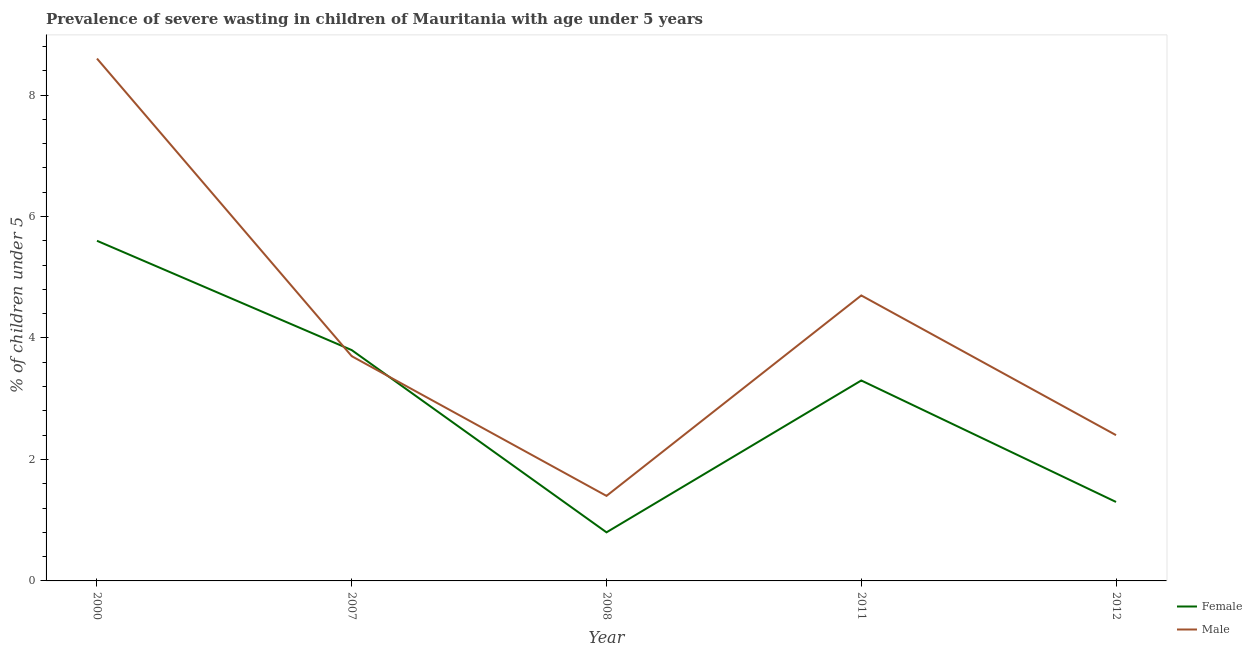Does the line corresponding to percentage of undernourished male children intersect with the line corresponding to percentage of undernourished female children?
Ensure brevity in your answer.  Yes. Is the number of lines equal to the number of legend labels?
Give a very brief answer. Yes. What is the percentage of undernourished female children in 2012?
Give a very brief answer. 1.3. Across all years, what is the maximum percentage of undernourished male children?
Make the answer very short. 8.6. Across all years, what is the minimum percentage of undernourished female children?
Your answer should be very brief. 0.8. What is the total percentage of undernourished female children in the graph?
Offer a terse response. 14.8. What is the difference between the percentage of undernourished female children in 2000 and that in 2007?
Make the answer very short. 1.8. What is the difference between the percentage of undernourished male children in 2008 and the percentage of undernourished female children in 2007?
Your response must be concise. -2.4. What is the average percentage of undernourished male children per year?
Give a very brief answer. 4.16. In the year 2011, what is the difference between the percentage of undernourished female children and percentage of undernourished male children?
Provide a short and direct response. -1.4. In how many years, is the percentage of undernourished male children greater than 1.6 %?
Provide a short and direct response. 4. What is the ratio of the percentage of undernourished female children in 2011 to that in 2012?
Make the answer very short. 2.54. Is the percentage of undernourished male children in 2007 less than that in 2012?
Keep it short and to the point. No. What is the difference between the highest and the second highest percentage of undernourished female children?
Keep it short and to the point. 1.8. What is the difference between the highest and the lowest percentage of undernourished female children?
Provide a succinct answer. 4.8. Is the sum of the percentage of undernourished male children in 2000 and 2011 greater than the maximum percentage of undernourished female children across all years?
Keep it short and to the point. Yes. Does the percentage of undernourished male children monotonically increase over the years?
Ensure brevity in your answer.  No. Is the percentage of undernourished female children strictly greater than the percentage of undernourished male children over the years?
Your answer should be very brief. No. How many years are there in the graph?
Your response must be concise. 5. What is the difference between two consecutive major ticks on the Y-axis?
Your answer should be compact. 2. Does the graph contain grids?
Offer a very short reply. No. Where does the legend appear in the graph?
Your answer should be very brief. Bottom right. How many legend labels are there?
Ensure brevity in your answer.  2. What is the title of the graph?
Provide a short and direct response. Prevalence of severe wasting in children of Mauritania with age under 5 years. Does "Private creditors" appear as one of the legend labels in the graph?
Offer a very short reply. No. What is the label or title of the X-axis?
Ensure brevity in your answer.  Year. What is the label or title of the Y-axis?
Your answer should be very brief.  % of children under 5. What is the  % of children under 5 in Female in 2000?
Offer a terse response. 5.6. What is the  % of children under 5 of Male in 2000?
Your answer should be compact. 8.6. What is the  % of children under 5 in Female in 2007?
Offer a terse response. 3.8. What is the  % of children under 5 of Male in 2007?
Keep it short and to the point. 3.7. What is the  % of children under 5 of Female in 2008?
Your answer should be very brief. 0.8. What is the  % of children under 5 of Male in 2008?
Make the answer very short. 1.4. What is the  % of children under 5 in Female in 2011?
Your answer should be very brief. 3.3. What is the  % of children under 5 of Male in 2011?
Keep it short and to the point. 4.7. What is the  % of children under 5 in Female in 2012?
Ensure brevity in your answer.  1.3. What is the  % of children under 5 of Male in 2012?
Your answer should be compact. 2.4. Across all years, what is the maximum  % of children under 5 of Female?
Your response must be concise. 5.6. Across all years, what is the maximum  % of children under 5 in Male?
Provide a short and direct response. 8.6. Across all years, what is the minimum  % of children under 5 of Female?
Your answer should be compact. 0.8. Across all years, what is the minimum  % of children under 5 in Male?
Make the answer very short. 1.4. What is the total  % of children under 5 in Female in the graph?
Offer a very short reply. 14.8. What is the total  % of children under 5 in Male in the graph?
Provide a succinct answer. 20.8. What is the difference between the  % of children under 5 in Female in 2000 and that in 2008?
Offer a terse response. 4.8. What is the difference between the  % of children under 5 of Male in 2000 and that in 2008?
Give a very brief answer. 7.2. What is the difference between the  % of children under 5 in Male in 2000 and that in 2012?
Provide a succinct answer. 6.2. What is the difference between the  % of children under 5 of Male in 2007 and that in 2011?
Provide a succinct answer. -1. What is the difference between the  % of children under 5 of Female in 2007 and that in 2012?
Keep it short and to the point. 2.5. What is the difference between the  % of children under 5 in Male in 2007 and that in 2012?
Your answer should be very brief. 1.3. What is the difference between the  % of children under 5 of Female in 2008 and that in 2011?
Ensure brevity in your answer.  -2.5. What is the difference between the  % of children under 5 in Male in 2008 and that in 2012?
Give a very brief answer. -1. What is the difference between the  % of children under 5 of Female in 2000 and the  % of children under 5 of Male in 2007?
Your answer should be very brief. 1.9. What is the difference between the  % of children under 5 of Female in 2000 and the  % of children under 5 of Male in 2008?
Offer a terse response. 4.2. What is the difference between the  % of children under 5 of Female in 2000 and the  % of children under 5 of Male in 2012?
Keep it short and to the point. 3.2. What is the difference between the  % of children under 5 in Female in 2007 and the  % of children under 5 in Male in 2008?
Offer a very short reply. 2.4. What is the difference between the  % of children under 5 of Female in 2007 and the  % of children under 5 of Male in 2011?
Your response must be concise. -0.9. What is the difference between the  % of children under 5 in Female in 2008 and the  % of children under 5 in Male in 2011?
Your answer should be compact. -3.9. What is the average  % of children under 5 of Female per year?
Your answer should be compact. 2.96. What is the average  % of children under 5 in Male per year?
Your answer should be very brief. 4.16. In the year 2008, what is the difference between the  % of children under 5 of Female and  % of children under 5 of Male?
Your answer should be very brief. -0.6. What is the ratio of the  % of children under 5 of Female in 2000 to that in 2007?
Give a very brief answer. 1.47. What is the ratio of the  % of children under 5 of Male in 2000 to that in 2007?
Offer a terse response. 2.32. What is the ratio of the  % of children under 5 of Male in 2000 to that in 2008?
Make the answer very short. 6.14. What is the ratio of the  % of children under 5 in Female in 2000 to that in 2011?
Provide a succinct answer. 1.7. What is the ratio of the  % of children under 5 in Male in 2000 to that in 2011?
Provide a succinct answer. 1.83. What is the ratio of the  % of children under 5 in Female in 2000 to that in 2012?
Ensure brevity in your answer.  4.31. What is the ratio of the  % of children under 5 of Male in 2000 to that in 2012?
Offer a terse response. 3.58. What is the ratio of the  % of children under 5 in Female in 2007 to that in 2008?
Offer a very short reply. 4.75. What is the ratio of the  % of children under 5 in Male in 2007 to that in 2008?
Offer a very short reply. 2.64. What is the ratio of the  % of children under 5 in Female in 2007 to that in 2011?
Give a very brief answer. 1.15. What is the ratio of the  % of children under 5 in Male in 2007 to that in 2011?
Provide a short and direct response. 0.79. What is the ratio of the  % of children under 5 in Female in 2007 to that in 2012?
Ensure brevity in your answer.  2.92. What is the ratio of the  % of children under 5 of Male in 2007 to that in 2012?
Provide a succinct answer. 1.54. What is the ratio of the  % of children under 5 in Female in 2008 to that in 2011?
Make the answer very short. 0.24. What is the ratio of the  % of children under 5 in Male in 2008 to that in 2011?
Give a very brief answer. 0.3. What is the ratio of the  % of children under 5 in Female in 2008 to that in 2012?
Keep it short and to the point. 0.62. What is the ratio of the  % of children under 5 in Male in 2008 to that in 2012?
Give a very brief answer. 0.58. What is the ratio of the  % of children under 5 of Female in 2011 to that in 2012?
Your answer should be very brief. 2.54. What is the ratio of the  % of children under 5 in Male in 2011 to that in 2012?
Offer a very short reply. 1.96. What is the difference between the highest and the second highest  % of children under 5 of Female?
Your answer should be very brief. 1.8. What is the difference between the highest and the second highest  % of children under 5 in Male?
Make the answer very short. 3.9. What is the difference between the highest and the lowest  % of children under 5 of Male?
Offer a terse response. 7.2. 